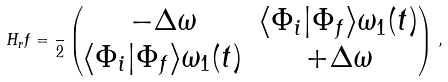Convert formula to latex. <formula><loc_0><loc_0><loc_500><loc_500>H _ { r } f = \frac { } { 2 } \begin{pmatrix} - \Delta \omega & \langle \Phi _ { i } | \Phi _ { f } \rangle \omega _ { 1 } ( t ) \\ \langle \Phi _ { i } | \Phi _ { f } \rangle \omega _ { 1 } ( t ) & + \Delta \omega \end{pmatrix} \, ,</formula> 